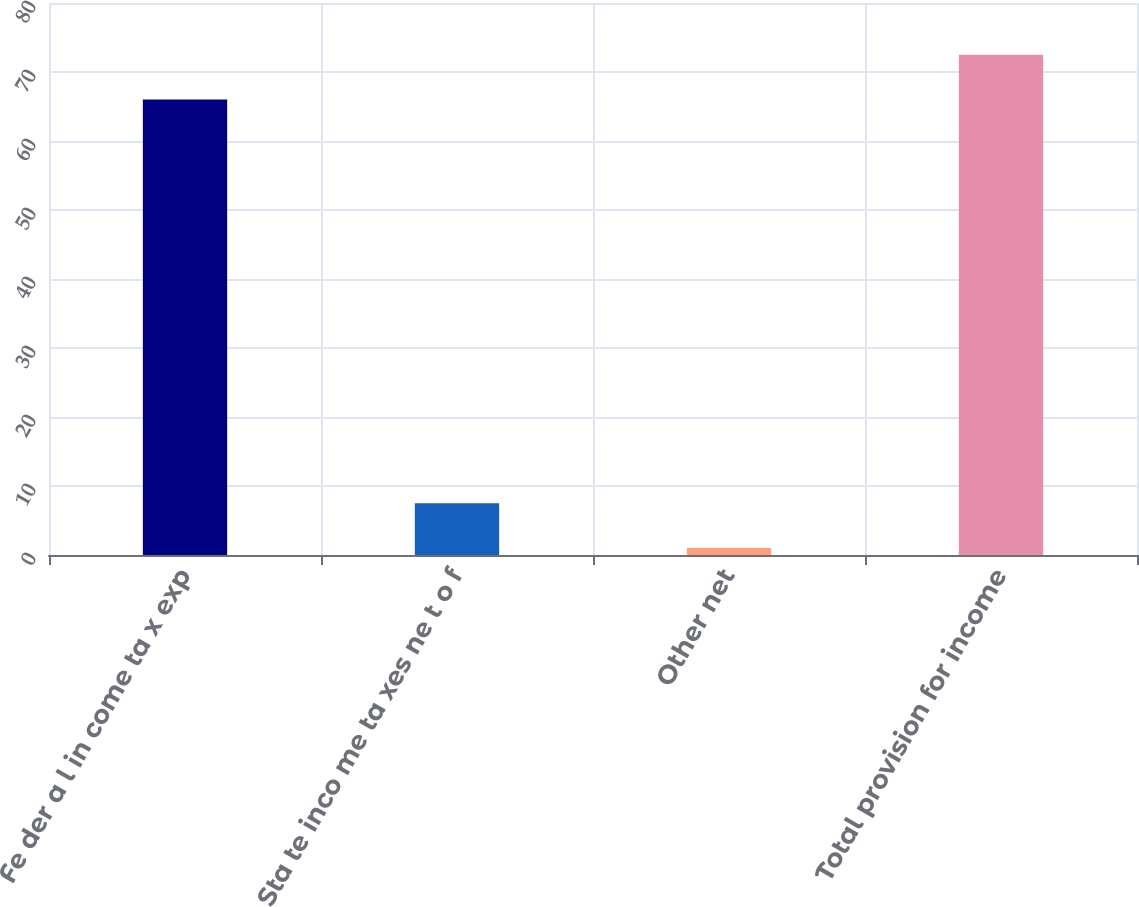<chart> <loc_0><loc_0><loc_500><loc_500><bar_chart><fcel>Fe der a l in come ta x exp<fcel>Sta te inco me ta xes ne t o f<fcel>Other net<fcel>Total provision for income<nl><fcel>66<fcel>7.5<fcel>1<fcel>72.5<nl></chart> 